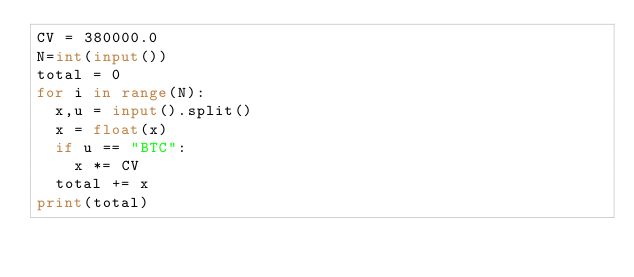Convert code to text. <code><loc_0><loc_0><loc_500><loc_500><_Python_>CV = 380000.0
N=int(input())
total = 0
for i in range(N):
  x,u = input().split()
  x = float(x)
  if u == "BTC":
    x *= CV
  total += x
print(total)</code> 